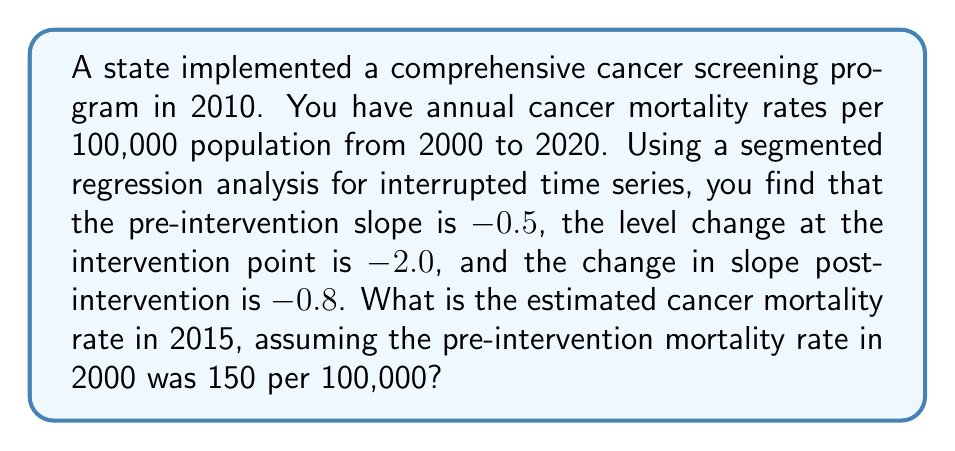Show me your answer to this math problem. Let's approach this step-by-step:

1) The segmented regression model for interrupted time series can be expressed as:

   $$Y_t = \beta_0 + \beta_1T + \beta_2X_t + \beta_3TX_t + \epsilon_t$$

   Where:
   $Y_t$ is the outcome at time t
   $T$ is the time since start of study
   $X_t$ is a dummy variable (0 pre-intervention, 1 post-intervention)
   $TX_t$ is an interaction term

2) From the question:
   $\beta_0 = 150$ (initial level in 2000)
   $\beta_1 = -0.5$ (pre-intervention slope)
   $\beta_2 = -2.0$ (level change at intervention)
   $\beta_3 = -0.8$ (change in slope post-intervention)

3) The intervention occurred in 2010, which is 10 years after the start.
   2015 is 5 years post-intervention and 15 years from the start.

4) For 2015:
   $T = 15$
   $X_t = 1$ (post-intervention)
   $TX_t = 15$ (interaction term)

5) Plugging into the equation:

   $$Y_{2015} = 150 + (-0.5 * 15) + (-2.0 * 1) + (-0.8 * 15)$$

6) Calculating:
   $$Y_{2015} = 150 - 7.5 - 2.0 - 12.0$$
   $$Y_{2015} = 128.5$$

Therefore, the estimated cancer mortality rate in 2015 is 128.5 per 100,000 population.
Answer: 128.5 per 100,000 